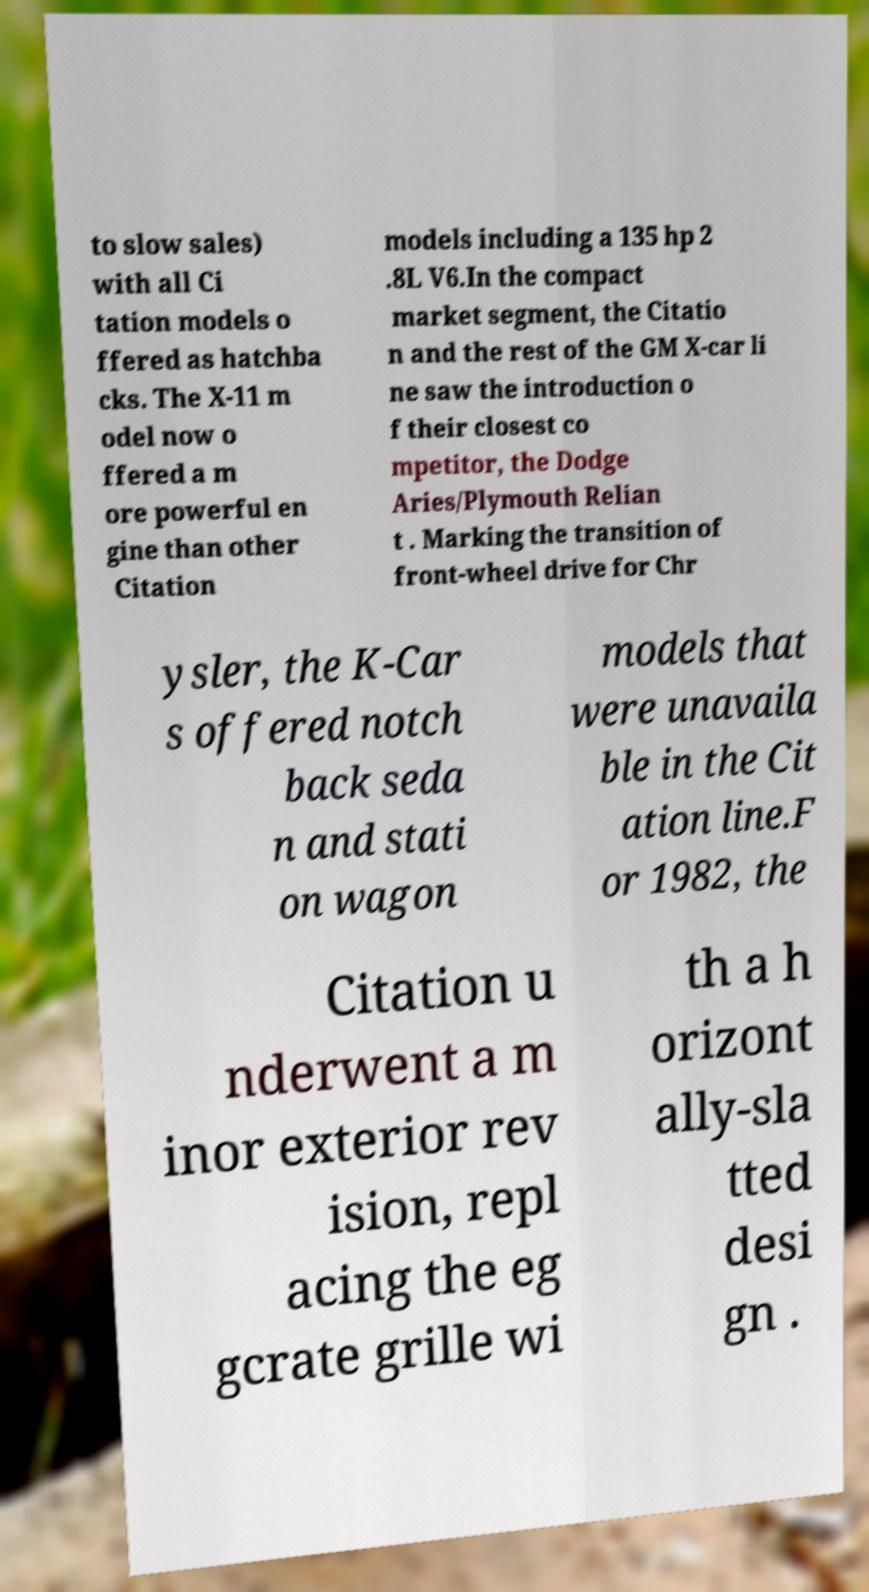Please identify and transcribe the text found in this image. to slow sales) with all Ci tation models o ffered as hatchba cks. The X-11 m odel now o ffered a m ore powerful en gine than other Citation models including a 135 hp 2 .8L V6.In the compact market segment, the Citatio n and the rest of the GM X-car li ne saw the introduction o f their closest co mpetitor, the Dodge Aries/Plymouth Relian t . Marking the transition of front-wheel drive for Chr ysler, the K-Car s offered notch back seda n and stati on wagon models that were unavaila ble in the Cit ation line.F or 1982, the Citation u nderwent a m inor exterior rev ision, repl acing the eg gcrate grille wi th a h orizont ally-sla tted desi gn . 